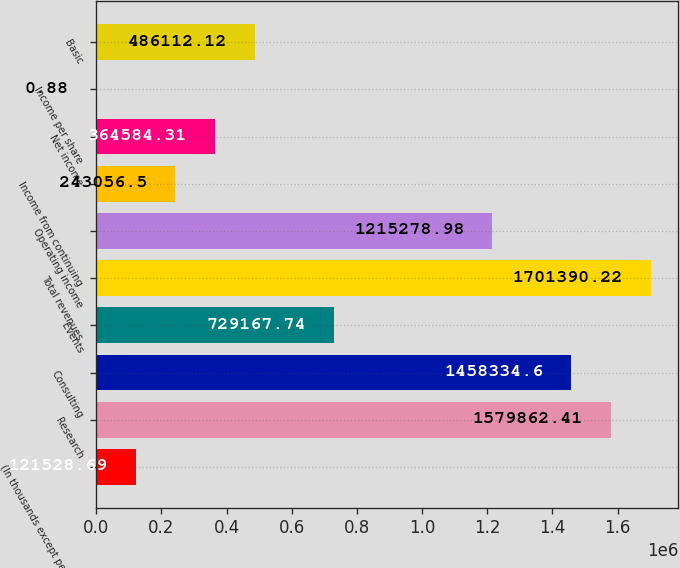Convert chart to OTSL. <chart><loc_0><loc_0><loc_500><loc_500><bar_chart><fcel>(In thousands except per share<fcel>Research<fcel>Consulting<fcel>Events<fcel>Total revenues<fcel>Operating income<fcel>Income from continuing<fcel>Net income<fcel>Income per share<fcel>Basic<nl><fcel>121529<fcel>1.57986e+06<fcel>1.45833e+06<fcel>729168<fcel>1.70139e+06<fcel>1.21528e+06<fcel>243056<fcel>364584<fcel>0.88<fcel>486112<nl></chart> 